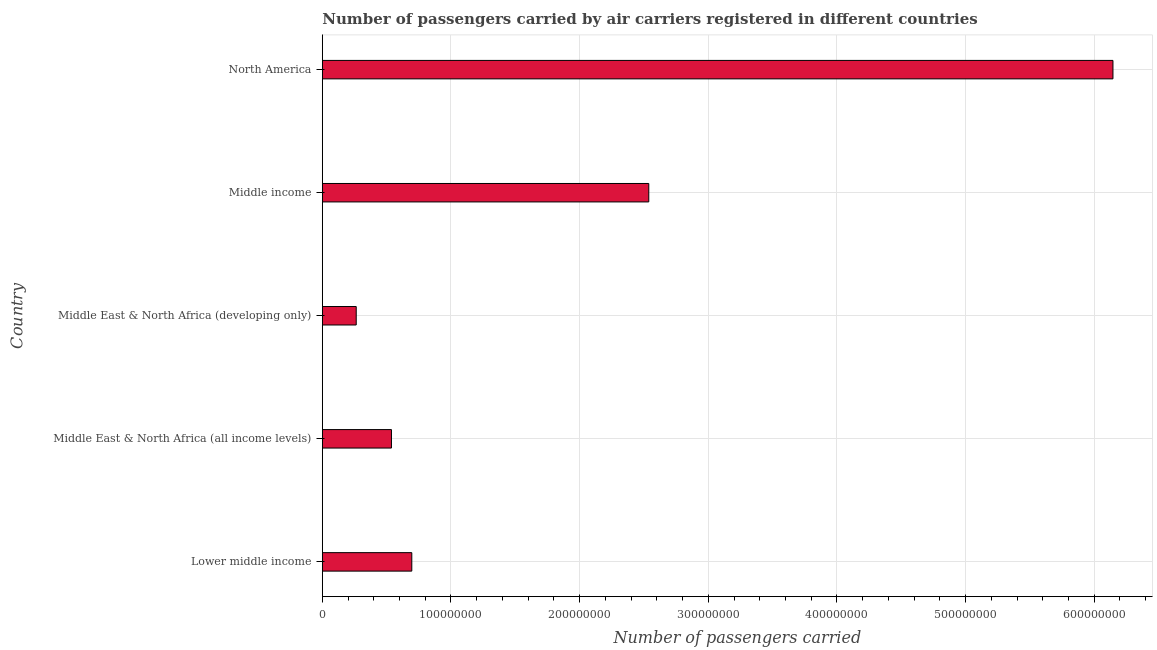Does the graph contain any zero values?
Offer a terse response. No. What is the title of the graph?
Make the answer very short. Number of passengers carried by air carriers registered in different countries. What is the label or title of the X-axis?
Your response must be concise. Number of passengers carried. What is the label or title of the Y-axis?
Provide a short and direct response. Country. What is the number of passengers carried in North America?
Your answer should be compact. 6.15e+08. Across all countries, what is the maximum number of passengers carried?
Your answer should be compact. 6.15e+08. Across all countries, what is the minimum number of passengers carried?
Your answer should be compact. 2.63e+07. In which country was the number of passengers carried maximum?
Offer a terse response. North America. In which country was the number of passengers carried minimum?
Your answer should be very brief. Middle East & North Africa (developing only). What is the sum of the number of passengers carried?
Offer a very short reply. 1.02e+09. What is the difference between the number of passengers carried in Middle East & North Africa (all income levels) and Middle East & North Africa (developing only)?
Offer a terse response. 2.74e+07. What is the average number of passengers carried per country?
Provide a short and direct response. 2.04e+08. What is the median number of passengers carried?
Provide a short and direct response. 6.95e+07. What is the ratio of the number of passengers carried in Middle East & North Africa (developing only) to that in North America?
Give a very brief answer. 0.04. Is the number of passengers carried in Middle East & North Africa (all income levels) less than that in Middle East & North Africa (developing only)?
Your answer should be very brief. No. Is the difference between the number of passengers carried in Middle East & North Africa (developing only) and North America greater than the difference between any two countries?
Offer a terse response. Yes. What is the difference between the highest and the second highest number of passengers carried?
Keep it short and to the point. 3.61e+08. Is the sum of the number of passengers carried in Lower middle income and North America greater than the maximum number of passengers carried across all countries?
Your answer should be compact. Yes. What is the difference between the highest and the lowest number of passengers carried?
Offer a terse response. 5.88e+08. How many bars are there?
Ensure brevity in your answer.  5. Are all the bars in the graph horizontal?
Your answer should be very brief. Yes. How many countries are there in the graph?
Your answer should be compact. 5. What is the difference between two consecutive major ticks on the X-axis?
Offer a very short reply. 1.00e+08. What is the Number of passengers carried of Lower middle income?
Provide a short and direct response. 6.95e+07. What is the Number of passengers carried in Middle East & North Africa (all income levels)?
Offer a very short reply. 5.37e+07. What is the Number of passengers carried of Middle East & North Africa (developing only)?
Ensure brevity in your answer.  2.63e+07. What is the Number of passengers carried of Middle income?
Your answer should be compact. 2.54e+08. What is the Number of passengers carried of North America?
Make the answer very short. 6.15e+08. What is the difference between the Number of passengers carried in Lower middle income and Middle East & North Africa (all income levels)?
Provide a short and direct response. 1.58e+07. What is the difference between the Number of passengers carried in Lower middle income and Middle East & North Africa (developing only)?
Your answer should be very brief. 4.32e+07. What is the difference between the Number of passengers carried in Lower middle income and Middle income?
Keep it short and to the point. -1.84e+08. What is the difference between the Number of passengers carried in Lower middle income and North America?
Make the answer very short. -5.45e+08. What is the difference between the Number of passengers carried in Middle East & North Africa (all income levels) and Middle East & North Africa (developing only)?
Your answer should be very brief. 2.74e+07. What is the difference between the Number of passengers carried in Middle East & North Africa (all income levels) and Middle income?
Ensure brevity in your answer.  -2.00e+08. What is the difference between the Number of passengers carried in Middle East & North Africa (all income levels) and North America?
Ensure brevity in your answer.  -5.61e+08. What is the difference between the Number of passengers carried in Middle East & North Africa (developing only) and Middle income?
Give a very brief answer. -2.27e+08. What is the difference between the Number of passengers carried in Middle East & North Africa (developing only) and North America?
Provide a succinct answer. -5.88e+08. What is the difference between the Number of passengers carried in Middle income and North America?
Make the answer very short. -3.61e+08. What is the ratio of the Number of passengers carried in Lower middle income to that in Middle East & North Africa (all income levels)?
Give a very brief answer. 1.29. What is the ratio of the Number of passengers carried in Lower middle income to that in Middle East & North Africa (developing only)?
Keep it short and to the point. 2.64. What is the ratio of the Number of passengers carried in Lower middle income to that in Middle income?
Ensure brevity in your answer.  0.27. What is the ratio of the Number of passengers carried in Lower middle income to that in North America?
Your response must be concise. 0.11. What is the ratio of the Number of passengers carried in Middle East & North Africa (all income levels) to that in Middle East & North Africa (developing only)?
Offer a terse response. 2.04. What is the ratio of the Number of passengers carried in Middle East & North Africa (all income levels) to that in Middle income?
Keep it short and to the point. 0.21. What is the ratio of the Number of passengers carried in Middle East & North Africa (all income levels) to that in North America?
Ensure brevity in your answer.  0.09. What is the ratio of the Number of passengers carried in Middle East & North Africa (developing only) to that in Middle income?
Offer a very short reply. 0.1. What is the ratio of the Number of passengers carried in Middle East & North Africa (developing only) to that in North America?
Provide a short and direct response. 0.04. What is the ratio of the Number of passengers carried in Middle income to that in North America?
Make the answer very short. 0.41. 